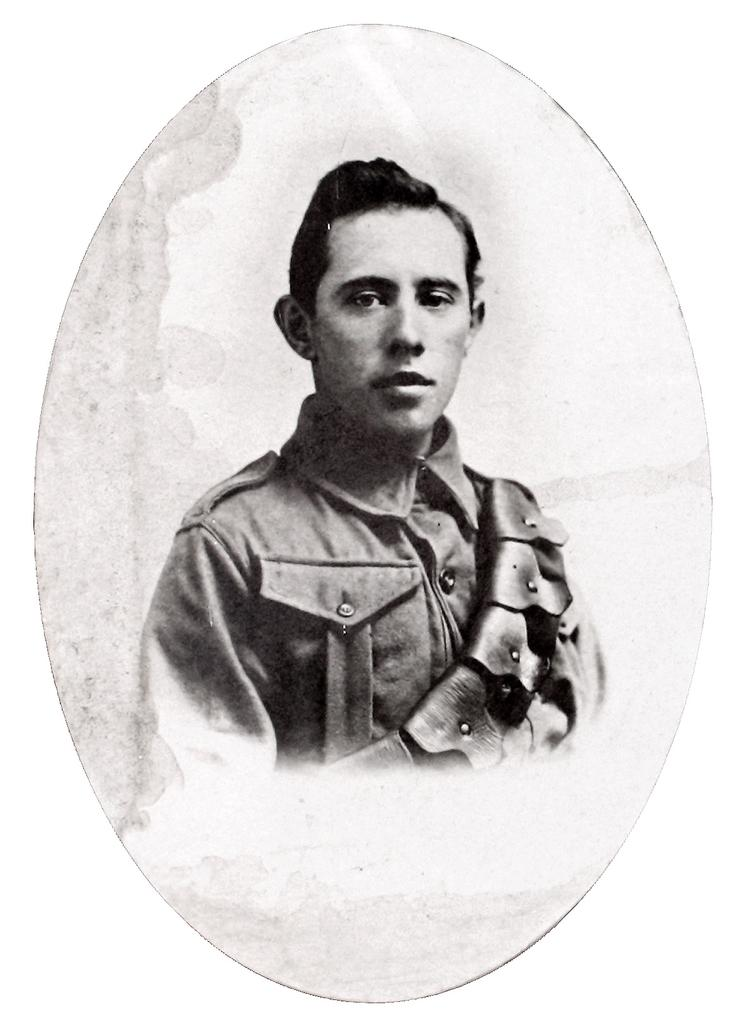What is the main subject of the image? There is a picture of a person in the image. What color are the borders of the image? The borders of the image are white in color. How does the person in the image rub their hands together? There is no indication in the image that the person is rubbing their hands together. 